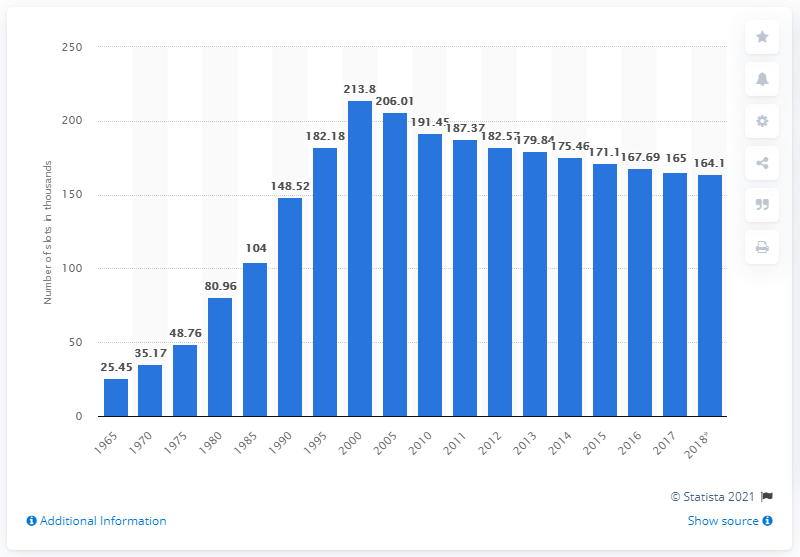Outline some significant characteristics in this image. The number of mobile gaming devices in Nevada reached its peak in the year 2000. For the year 2000, the number of casino gaming devices in Nevada decreased. In 2018, there were 164.1 slot machines in Nevada casinos. 